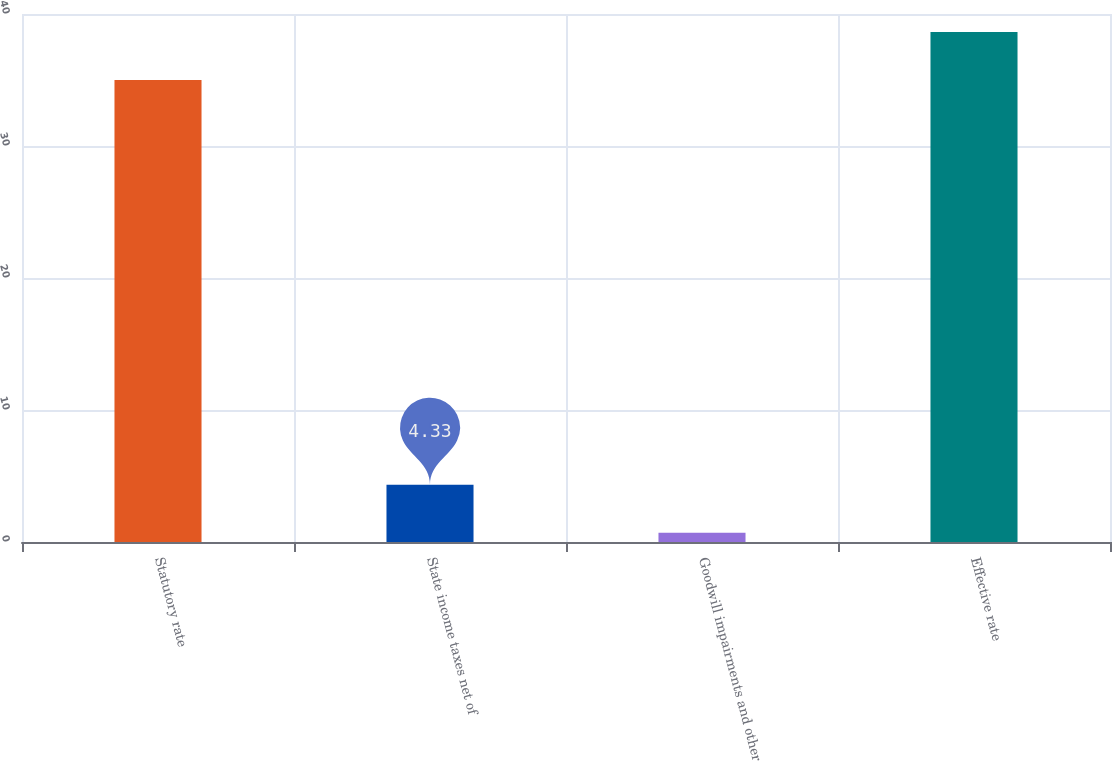Convert chart to OTSL. <chart><loc_0><loc_0><loc_500><loc_500><bar_chart><fcel>Statutory rate<fcel>State income taxes net of<fcel>Goodwill impairments and other<fcel>Effective rate<nl><fcel>35<fcel>4.33<fcel>0.7<fcel>38.63<nl></chart> 